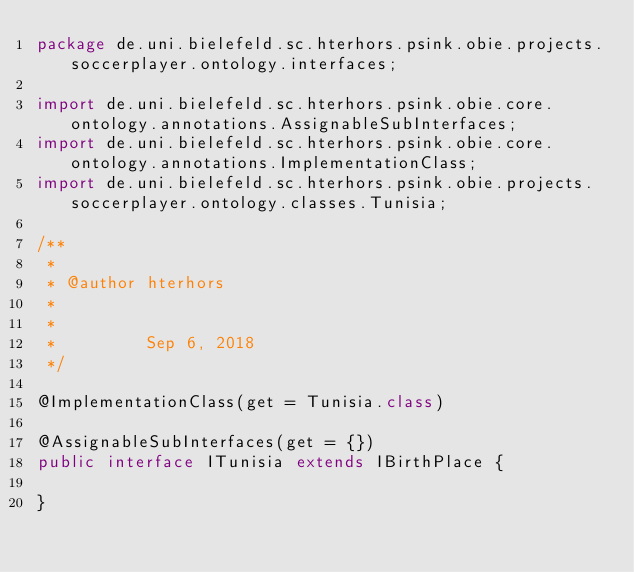<code> <loc_0><loc_0><loc_500><loc_500><_Java_>package de.uni.bielefeld.sc.hterhors.psink.obie.projects.soccerplayer.ontology.interfaces;

import de.uni.bielefeld.sc.hterhors.psink.obie.core.ontology.annotations.AssignableSubInterfaces;
import de.uni.bielefeld.sc.hterhors.psink.obie.core.ontology.annotations.ImplementationClass;
import de.uni.bielefeld.sc.hterhors.psink.obie.projects.soccerplayer.ontology.classes.Tunisia;

/**
 *
 * @author hterhors
 *
 *
 *         Sep 6, 2018
 */

@ImplementationClass(get = Tunisia.class)

@AssignableSubInterfaces(get = {})
public interface ITunisia extends IBirthPlace {

}
</code> 